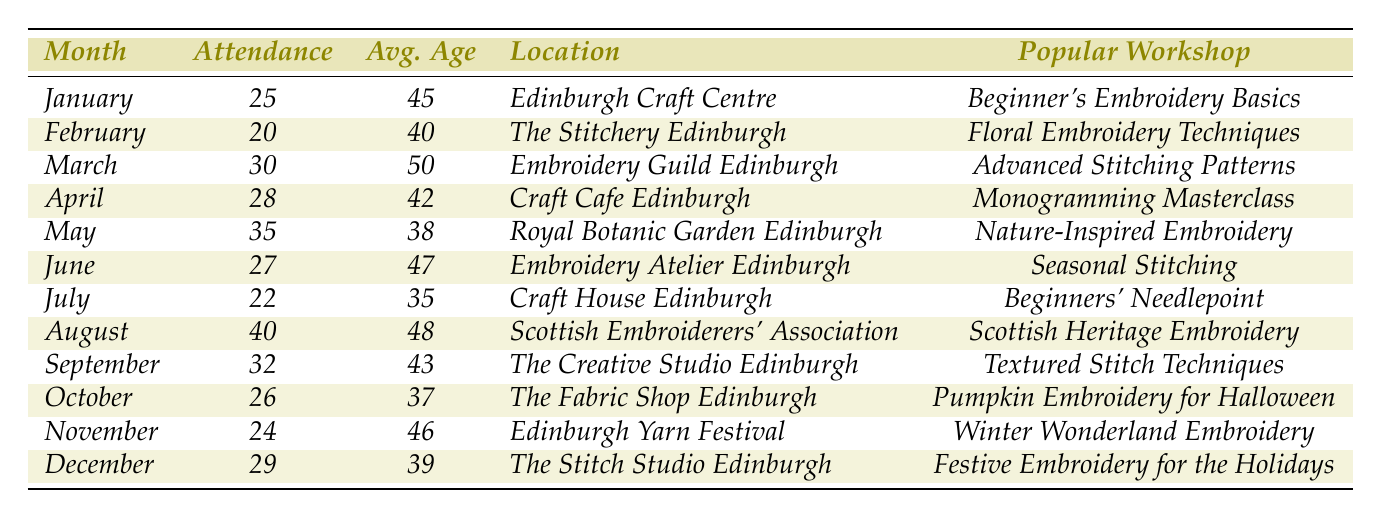What was the highest workshop attendance recorded in Edinburgh in 2023? The highest attendance was found by comparing the attendance figures for each month. August had the highest attendance at 40.
Answer: 40 Which month had an average age of attendees above 45? To find months with an average age above 45, I considered the average ages: January (45), February (40), March (50), April (42), May (38), June (47), July (35), August (48), September (43), October (37), November (46), and December (39). March, June, August, and November are above 45.
Answer: March, June, August, November What is the total attendance across all months? I calculated the total attendance by summing the attendance figures for all months: 25 + 20 + 30 + 28 + 35 + 27 + 22 + 40 + 32 + 26 + 24 + 29 =  302.
Answer: 302 Was there a workshop focused on a seasonal theme in any month? By checking the popular workshops for each month, June had "Seasonal Stitching," indicating a seasonal theme.
Answer: Yes Which workshop had the lowest attendance, and what was the attendance figure? The month with the lowest attendance was February, with 20 attendees.
Answer: 20 What is the average age of attendees in workshops held in March and August? I found the average ages for March (50) and August (48) and calculated their average: (50 + 48) / 2 = 49.
Answer: 49 Which locations hosted workshops with average attendee ages below 40? I checked the average ages for each month: January (45), February (40), March (50), April (42), May (38), June (47), July (35), August (48), September (43), October (37), November (46), and December (39). The only month below 40 is July (35) at Craft House Edinburgh.
Answer: July (Craft House Edinburgh) How many more attendees were present in May than in April? To find this, I calculated the difference in attendance: May (35) - April (28) = 7 more attendees in May than in April.
Answer: 7 Was the average attendance for the second half of the year greater than that of the first half? The total attendance for the first half (January-June) is 25 + 20 + 30 + 28 + 35 + 27 = 165. The total for the second half (July-December) is 22 + 40 + 32 + 26 + 24 + 29 = 173. Since 173 > 165, the average for the second half is greater.
Answer: Yes What popular workshop was held in October, and what was the average age? The popular workshop in October was "Pumpkin Embroidery for Halloween," with an average age of 37.
Answer: Pumpkin Embroidery for Halloween, 37 